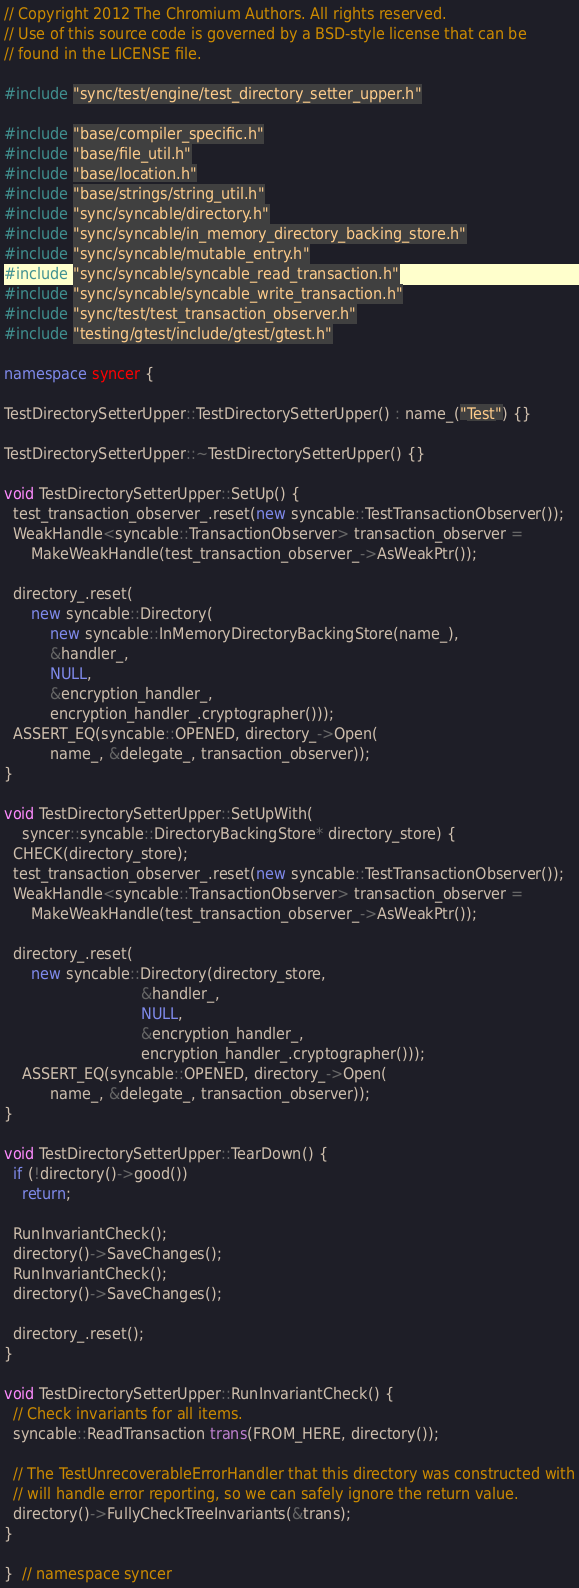<code> <loc_0><loc_0><loc_500><loc_500><_C++_>// Copyright 2012 The Chromium Authors. All rights reserved.
// Use of this source code is governed by a BSD-style license that can be
// found in the LICENSE file.

#include "sync/test/engine/test_directory_setter_upper.h"

#include "base/compiler_specific.h"
#include "base/file_util.h"
#include "base/location.h"
#include "base/strings/string_util.h"
#include "sync/syncable/directory.h"
#include "sync/syncable/in_memory_directory_backing_store.h"
#include "sync/syncable/mutable_entry.h"
#include "sync/syncable/syncable_read_transaction.h"
#include "sync/syncable/syncable_write_transaction.h"
#include "sync/test/test_transaction_observer.h"
#include "testing/gtest/include/gtest/gtest.h"

namespace syncer {

TestDirectorySetterUpper::TestDirectorySetterUpper() : name_("Test") {}

TestDirectorySetterUpper::~TestDirectorySetterUpper() {}

void TestDirectorySetterUpper::SetUp() {
  test_transaction_observer_.reset(new syncable::TestTransactionObserver());
  WeakHandle<syncable::TransactionObserver> transaction_observer =
      MakeWeakHandle(test_transaction_observer_->AsWeakPtr());

  directory_.reset(
      new syncable::Directory(
          new syncable::InMemoryDirectoryBackingStore(name_),
          &handler_,
          NULL,
          &encryption_handler_,
          encryption_handler_.cryptographer()));
  ASSERT_EQ(syncable::OPENED, directory_->Open(
          name_, &delegate_, transaction_observer));
}

void TestDirectorySetterUpper::SetUpWith(
    syncer::syncable::DirectoryBackingStore* directory_store) {
  CHECK(directory_store);
  test_transaction_observer_.reset(new syncable::TestTransactionObserver());
  WeakHandle<syncable::TransactionObserver> transaction_observer =
      MakeWeakHandle(test_transaction_observer_->AsWeakPtr());

  directory_.reset(
      new syncable::Directory(directory_store,
                              &handler_,
                              NULL,
                              &encryption_handler_,
                              encryption_handler_.cryptographer()));
    ASSERT_EQ(syncable::OPENED, directory_->Open(
          name_, &delegate_, transaction_observer));
}

void TestDirectorySetterUpper::TearDown() {
  if (!directory()->good())
    return;

  RunInvariantCheck();
  directory()->SaveChanges();
  RunInvariantCheck();
  directory()->SaveChanges();

  directory_.reset();
}

void TestDirectorySetterUpper::RunInvariantCheck() {
  // Check invariants for all items.
  syncable::ReadTransaction trans(FROM_HERE, directory());

  // The TestUnrecoverableErrorHandler that this directory was constructed with
  // will handle error reporting, so we can safely ignore the return value.
  directory()->FullyCheckTreeInvariants(&trans);
}

}  // namespace syncer
</code> 